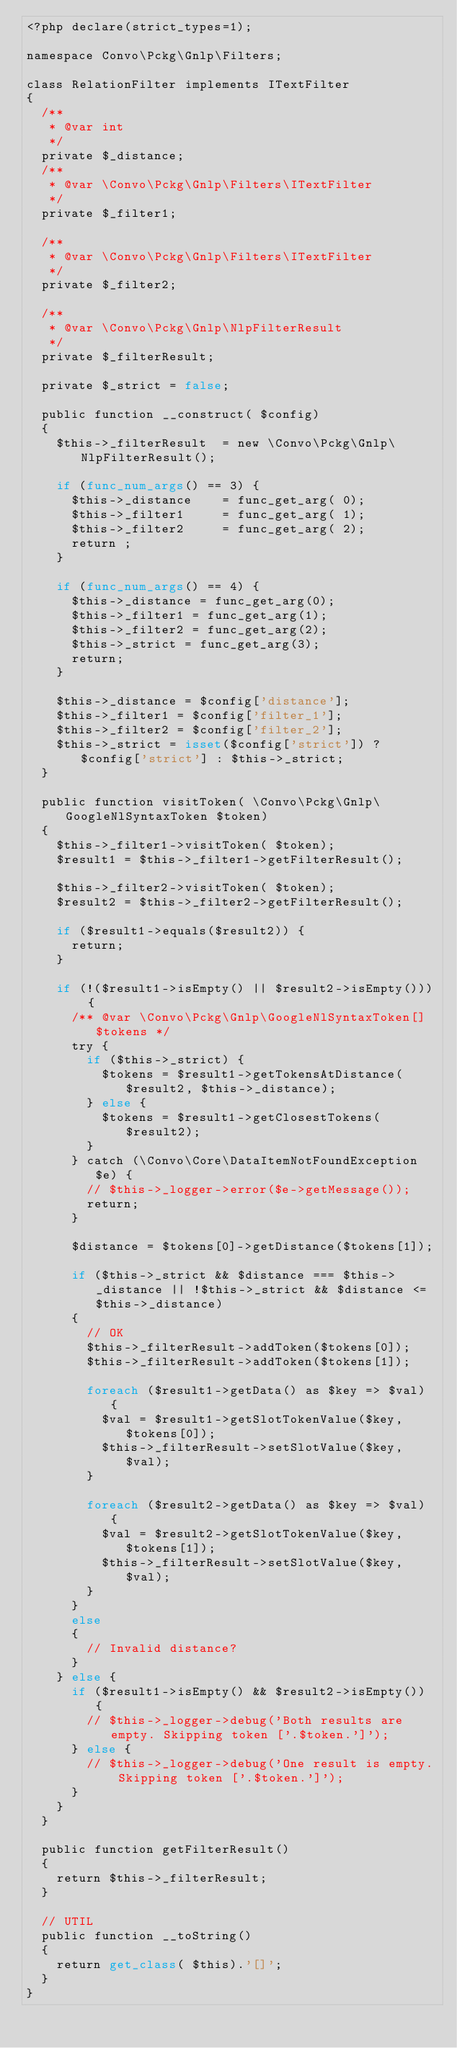<code> <loc_0><loc_0><loc_500><loc_500><_PHP_><?php declare(strict_types=1);

namespace Convo\Pckg\Gnlp\Filters;

class RelationFilter implements ITextFilter
{
	/**
	 * @var int
	 */
	private $_distance;
	/**
	 * @var \Convo\Pckg\Gnlp\Filters\ITextFilter
	 */
	private $_filter1;
	
	/**
	 * @var \Convo\Pckg\Gnlp\Filters\ITextFilter
	 */
	private $_filter2;
	
	/**
	 * @var \Convo\Pckg\Gnlp\NlpFilterResult
	 */
	private $_filterResult;

	private $_strict = false;
	
	public function __construct( $config)
	{
		$this->_filterResult	=	new \Convo\Pckg\Gnlp\NlpFilterResult();
		
		if (func_num_args() == 3) {
			$this->_distance		=	func_get_arg( 0);
			$this->_filter1			=	func_get_arg( 1);
			$this->_filter2			=	func_get_arg( 2);
			return ;
		}
		
		if (func_num_args() == 4) {
			$this->_distance = func_get_arg(0);
			$this->_filter1 = func_get_arg(1);
			$this->_filter2 = func_get_arg(2);
			$this->_strict = func_get_arg(3);
			return;
		}

		$this->_distance = $config['distance'];
		$this->_filter1 = $config['filter_1'];
		$this->_filter2 = $config['filter_2'];
		$this->_strict = isset($config['strict']) ? $config['strict'] : $this->_strict;
	}
	
	public function visitToken( \Convo\Pckg\Gnlp\GoogleNlSyntaxToken $token)
	{
		$this->_filter1->visitToken( $token);
		$result1 = $this->_filter1->getFilterResult();
		
		$this->_filter2->visitToken( $token);
		$result2 = $this->_filter2->getFilterResult();
		
		if ($result1->equals($result2)) {
			return;
		}

		if (!($result1->isEmpty() || $result2->isEmpty())) {
			/** @var \Convo\Pckg\Gnlp\GoogleNlSyntaxToken[] $tokens */
			try {
				if ($this->_strict) {
					$tokens = $result1->getTokensAtDistance($result2, $this->_distance);
				} else {
					$tokens = $result1->getClosestTokens($result2);
				}
			} catch (\Convo\Core\DataItemNotFoundException $e) {
				// $this->_logger->error($e->getMessage());
				return;
			}

			$distance = $tokens[0]->getDistance($tokens[1]);

			if ($this->_strict && $distance === $this->_distance || !$this->_strict && $distance <= $this->_distance)
			{
				// OK
				$this->_filterResult->addToken($tokens[0]);
				$this->_filterResult->addToken($tokens[1]);

				foreach ($result1->getData() as $key => $val) {
					$val = $result1->getSlotTokenValue($key, $tokens[0]);
					$this->_filterResult->setSlotValue($key, $val);
				}

				foreach ($result2->getData() as $key => $val) {
					$val = $result2->getSlotTokenValue($key, $tokens[1]);
					$this->_filterResult->setSlotValue($key, $val);
				}
			}
			else
			{
				// Invalid distance?
			}
		} else {
			if ($result1->isEmpty() && $result2->isEmpty()) {
				// $this->_logger->debug('Both results are empty. Skipping token ['.$token.']');
			} else {
				// $this->_logger->debug('One result is empty. Skipping token ['.$token.']');
			}
		}
	}
	
	public function getFilterResult()
	{
		return $this->_filterResult;
	}
	
	// UTIL
	public function __toString()
	{
		return get_class( $this).'[]';
	}
}</code> 